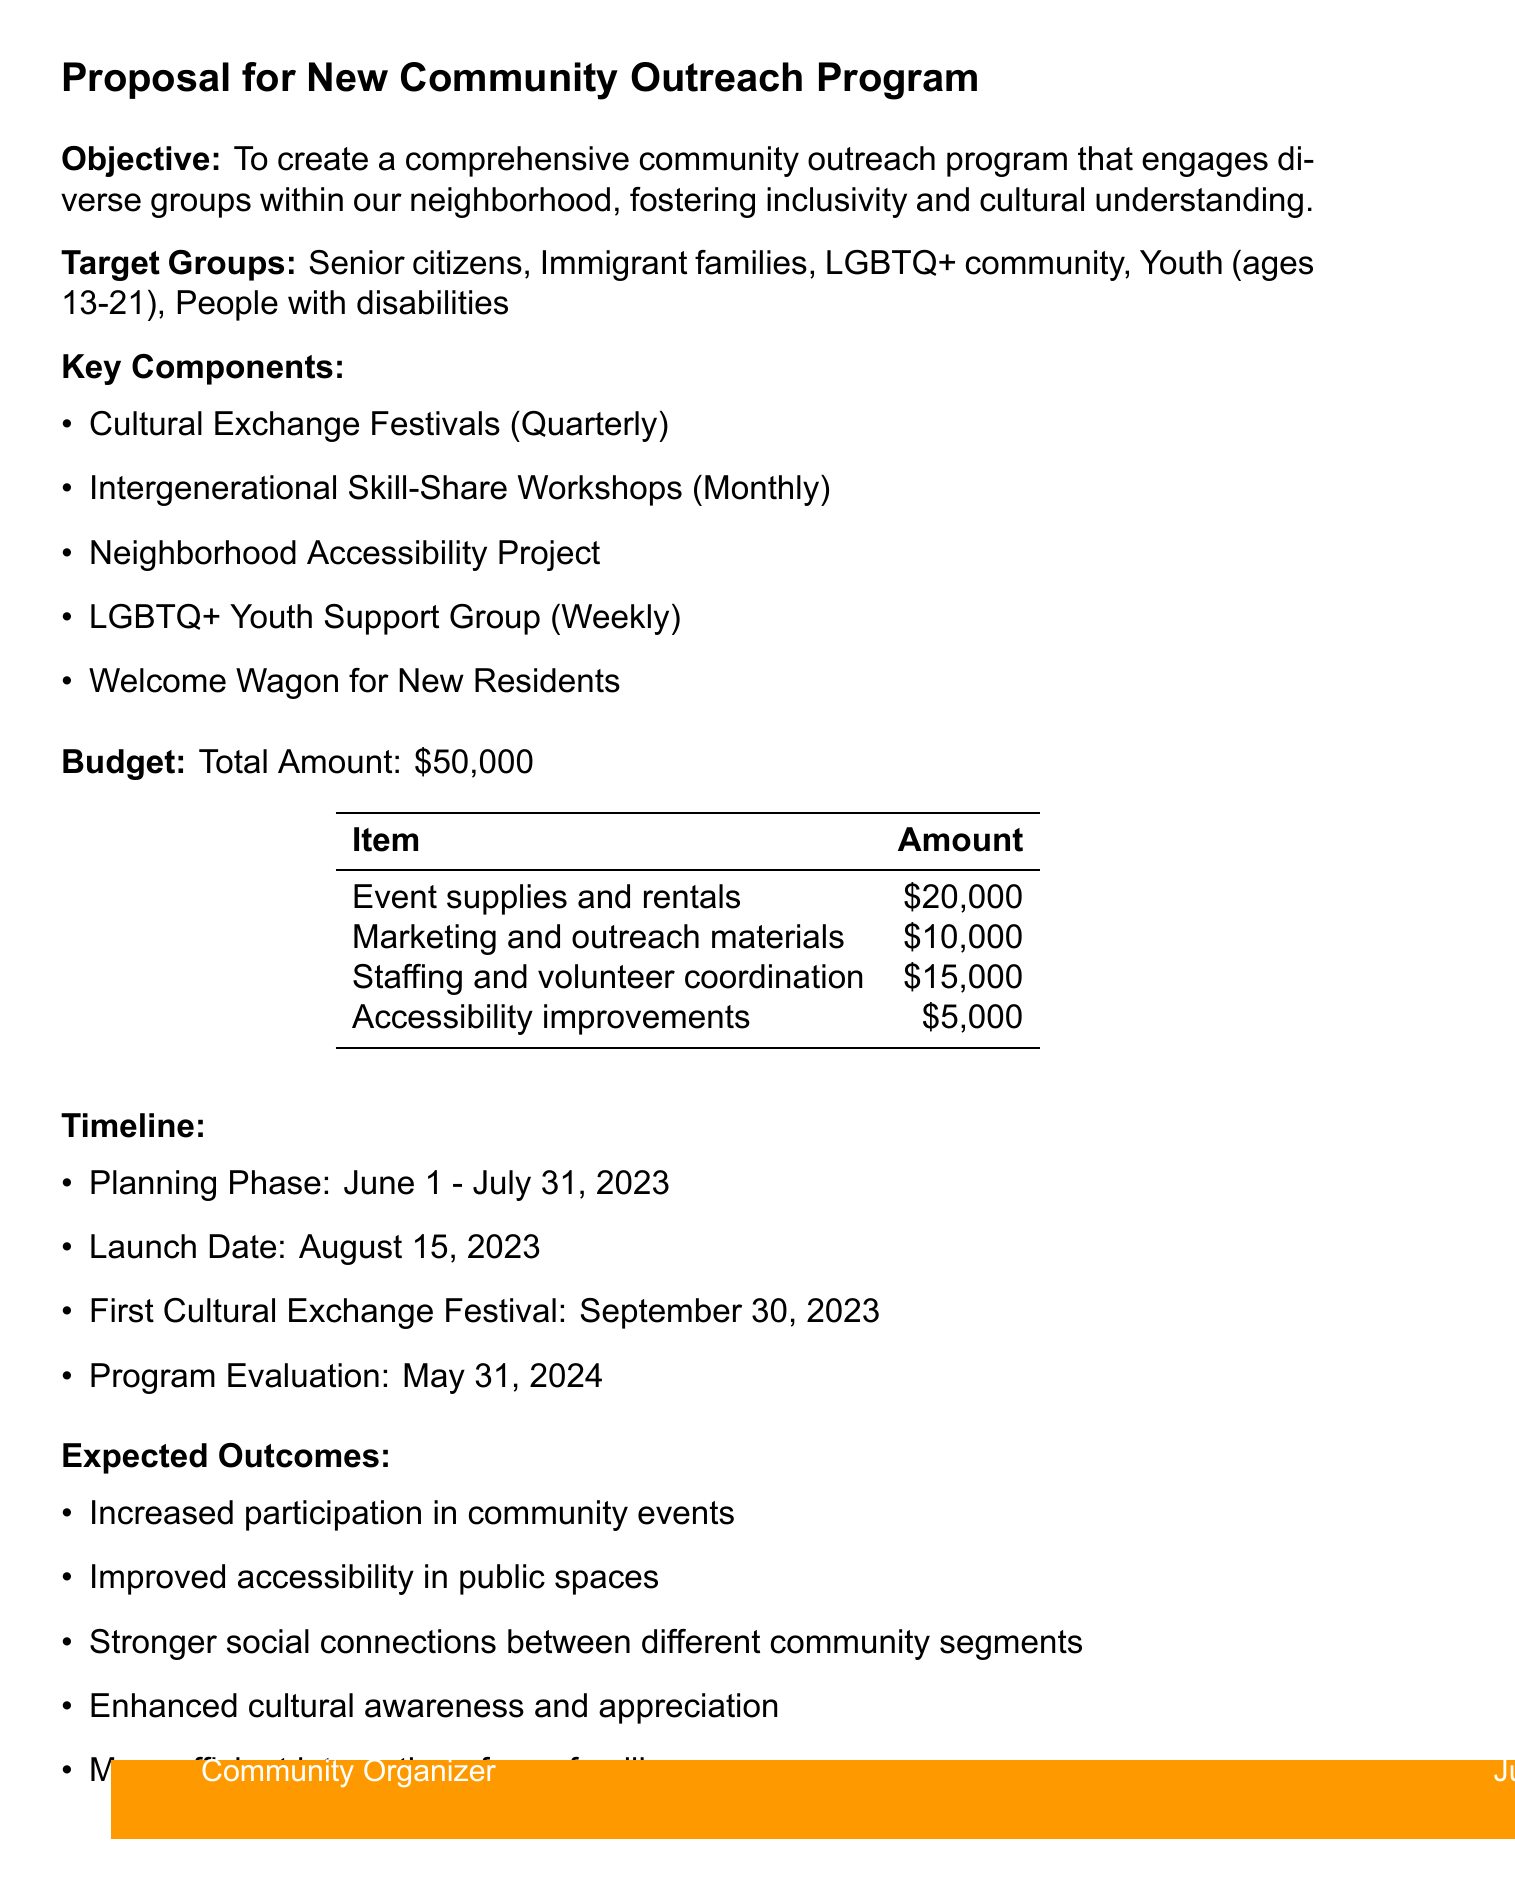What is the program name? The program name is clearly stated at the top of the document as "Neighborhood Unity Initiative."
Answer: Neighborhood Unity Initiative What is the total budget amount? The total budget amount is specified in the budget section of the document as $50,000.
Answer: $50,000 What is the frequency of the Cultural Exchange Festivals? The frequency is mentioned in the key components, indicating they occur "Every 3 months."
Answer: Every 3 months Who is responsible for the Welcome Wagon program? The document states that this program is to be organized by "Existing community members."
Answer: Existing community members What date is the launch planned for? The launch date is detailed in the timeline section as "August 15, 2023."
Answer: August 15, 2023 Which group meets weekly for support? The document explicitly states that the "LGBTQ+ Youth Support Group" meets weekly for support.
Answer: LGBTQ+ Youth Support Group What partners are involved in the Neighborhood Accessibility Project? The document lists "Local Disability Rights Organization" and "City Planning Department" as partners in this project.
Answer: Local Disability Rights Organization, City Planning Department What is one expected outcome of the program? The expected outcomes section lists multiple results, one being "Increased participation in community events across all demographic groups."
Answer: Increased participation in community events across all demographic groups What are the evaluation methods mentioned? The document outlines various evaluation methods, one being "Quarterly surveys of program participants."
Answer: Quarterly surveys of program participants 